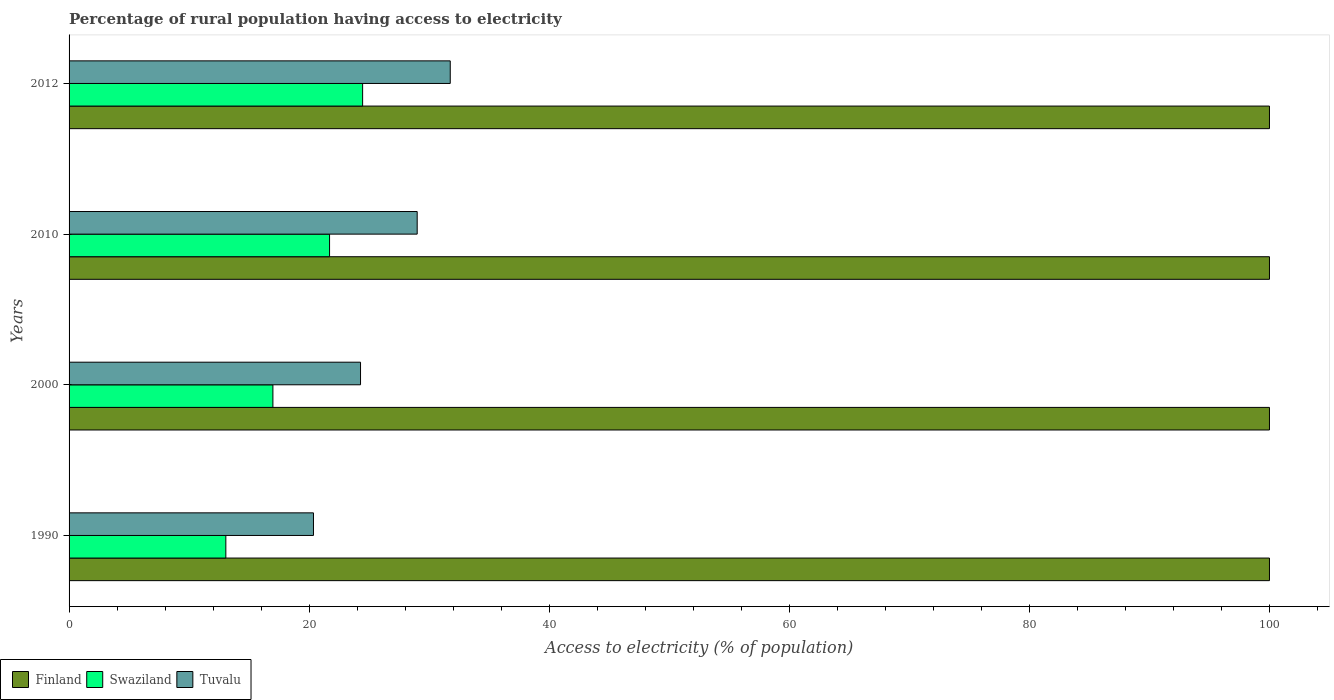How many groups of bars are there?
Offer a very short reply. 4. Are the number of bars on each tick of the Y-axis equal?
Offer a very short reply. Yes. What is the label of the 3rd group of bars from the top?
Provide a short and direct response. 2000. What is the percentage of rural population having access to electricity in Swaziland in 2000?
Make the answer very short. 16.98. Across all years, what is the maximum percentage of rural population having access to electricity in Swaziland?
Your answer should be very brief. 24.45. Across all years, what is the minimum percentage of rural population having access to electricity in Tuvalu?
Provide a short and direct response. 20.36. In which year was the percentage of rural population having access to electricity in Tuvalu maximum?
Ensure brevity in your answer.  2012. In which year was the percentage of rural population having access to electricity in Tuvalu minimum?
Ensure brevity in your answer.  1990. What is the total percentage of rural population having access to electricity in Swaziland in the graph?
Provide a short and direct response. 76.2. What is the difference between the percentage of rural population having access to electricity in Tuvalu in 2000 and that in 2010?
Your answer should be compact. -4.72. What is the difference between the percentage of rural population having access to electricity in Tuvalu in 1990 and the percentage of rural population having access to electricity in Finland in 2010?
Keep it short and to the point. -79.64. In the year 1990, what is the difference between the percentage of rural population having access to electricity in Tuvalu and percentage of rural population having access to electricity in Swaziland?
Provide a short and direct response. 7.3. In how many years, is the percentage of rural population having access to electricity in Tuvalu greater than 44 %?
Make the answer very short. 0. Is the difference between the percentage of rural population having access to electricity in Tuvalu in 1990 and 2000 greater than the difference between the percentage of rural population having access to electricity in Swaziland in 1990 and 2000?
Your answer should be compact. Yes. What is the difference between the highest and the second highest percentage of rural population having access to electricity in Tuvalu?
Offer a terse response. 2.75. What is the difference between the highest and the lowest percentage of rural population having access to electricity in Swaziland?
Your answer should be very brief. 11.39. What does the 2nd bar from the top in 2012 represents?
Keep it short and to the point. Swaziland. What does the 3rd bar from the bottom in 2010 represents?
Ensure brevity in your answer.  Tuvalu. How many bars are there?
Keep it short and to the point. 12. Does the graph contain grids?
Ensure brevity in your answer.  No. Where does the legend appear in the graph?
Make the answer very short. Bottom left. How are the legend labels stacked?
Offer a terse response. Horizontal. What is the title of the graph?
Provide a succinct answer. Percentage of rural population having access to electricity. Does "Bangladesh" appear as one of the legend labels in the graph?
Give a very brief answer. No. What is the label or title of the X-axis?
Your response must be concise. Access to electricity (% of population). What is the Access to electricity (% of population) in Swaziland in 1990?
Provide a short and direct response. 13.06. What is the Access to electricity (% of population) of Tuvalu in 1990?
Your response must be concise. 20.36. What is the Access to electricity (% of population) of Swaziland in 2000?
Your response must be concise. 16.98. What is the Access to electricity (% of population) in Tuvalu in 2000?
Offer a terse response. 24.28. What is the Access to electricity (% of population) of Swaziland in 2010?
Offer a very short reply. 21.7. What is the Access to electricity (% of population) in Tuvalu in 2010?
Your answer should be very brief. 29. What is the Access to electricity (% of population) of Finland in 2012?
Offer a very short reply. 100. What is the Access to electricity (% of population) in Swaziland in 2012?
Provide a short and direct response. 24.45. What is the Access to electricity (% of population) in Tuvalu in 2012?
Ensure brevity in your answer.  31.75. Across all years, what is the maximum Access to electricity (% of population) in Finland?
Your answer should be very brief. 100. Across all years, what is the maximum Access to electricity (% of population) of Swaziland?
Your answer should be compact. 24.45. Across all years, what is the maximum Access to electricity (% of population) of Tuvalu?
Offer a terse response. 31.75. Across all years, what is the minimum Access to electricity (% of population) in Swaziland?
Your answer should be compact. 13.06. Across all years, what is the minimum Access to electricity (% of population) in Tuvalu?
Ensure brevity in your answer.  20.36. What is the total Access to electricity (% of population) in Swaziland in the graph?
Offer a very short reply. 76.2. What is the total Access to electricity (% of population) in Tuvalu in the graph?
Ensure brevity in your answer.  105.4. What is the difference between the Access to electricity (% of population) of Finland in 1990 and that in 2000?
Your answer should be very brief. 0. What is the difference between the Access to electricity (% of population) of Swaziland in 1990 and that in 2000?
Offer a very short reply. -3.92. What is the difference between the Access to electricity (% of population) of Tuvalu in 1990 and that in 2000?
Offer a terse response. -3.92. What is the difference between the Access to electricity (% of population) in Finland in 1990 and that in 2010?
Your answer should be compact. 0. What is the difference between the Access to electricity (% of population) of Swaziland in 1990 and that in 2010?
Ensure brevity in your answer.  -8.64. What is the difference between the Access to electricity (% of population) in Tuvalu in 1990 and that in 2010?
Your answer should be very brief. -8.64. What is the difference between the Access to electricity (% of population) of Finland in 1990 and that in 2012?
Ensure brevity in your answer.  0. What is the difference between the Access to electricity (% of population) of Swaziland in 1990 and that in 2012?
Provide a succinct answer. -11.39. What is the difference between the Access to electricity (% of population) of Tuvalu in 1990 and that in 2012?
Keep it short and to the point. -11.39. What is the difference between the Access to electricity (% of population) in Finland in 2000 and that in 2010?
Make the answer very short. 0. What is the difference between the Access to electricity (% of population) in Swaziland in 2000 and that in 2010?
Offer a terse response. -4.72. What is the difference between the Access to electricity (% of population) of Tuvalu in 2000 and that in 2010?
Your answer should be very brief. -4.72. What is the difference between the Access to electricity (% of population) in Swaziland in 2000 and that in 2012?
Give a very brief answer. -7.47. What is the difference between the Access to electricity (% of population) in Tuvalu in 2000 and that in 2012?
Your response must be concise. -7.47. What is the difference between the Access to electricity (% of population) in Finland in 2010 and that in 2012?
Your answer should be compact. 0. What is the difference between the Access to electricity (% of population) of Swaziland in 2010 and that in 2012?
Keep it short and to the point. -2.75. What is the difference between the Access to electricity (% of population) in Tuvalu in 2010 and that in 2012?
Offer a very short reply. -2.75. What is the difference between the Access to electricity (% of population) in Finland in 1990 and the Access to electricity (% of population) in Swaziland in 2000?
Your response must be concise. 83.02. What is the difference between the Access to electricity (% of population) in Finland in 1990 and the Access to electricity (% of population) in Tuvalu in 2000?
Your answer should be very brief. 75.72. What is the difference between the Access to electricity (% of population) in Swaziland in 1990 and the Access to electricity (% of population) in Tuvalu in 2000?
Offer a very short reply. -11.22. What is the difference between the Access to electricity (% of population) in Finland in 1990 and the Access to electricity (% of population) in Swaziland in 2010?
Provide a short and direct response. 78.3. What is the difference between the Access to electricity (% of population) in Swaziland in 1990 and the Access to electricity (% of population) in Tuvalu in 2010?
Ensure brevity in your answer.  -15.94. What is the difference between the Access to electricity (% of population) in Finland in 1990 and the Access to electricity (% of population) in Swaziland in 2012?
Your answer should be very brief. 75.55. What is the difference between the Access to electricity (% of population) of Finland in 1990 and the Access to electricity (% of population) of Tuvalu in 2012?
Provide a succinct answer. 68.25. What is the difference between the Access to electricity (% of population) of Swaziland in 1990 and the Access to electricity (% of population) of Tuvalu in 2012?
Offer a very short reply. -18.69. What is the difference between the Access to electricity (% of population) in Finland in 2000 and the Access to electricity (% of population) in Swaziland in 2010?
Provide a short and direct response. 78.3. What is the difference between the Access to electricity (% of population) of Finland in 2000 and the Access to electricity (% of population) of Tuvalu in 2010?
Keep it short and to the point. 71. What is the difference between the Access to electricity (% of population) of Swaziland in 2000 and the Access to electricity (% of population) of Tuvalu in 2010?
Ensure brevity in your answer.  -12.02. What is the difference between the Access to electricity (% of population) of Finland in 2000 and the Access to electricity (% of population) of Swaziland in 2012?
Offer a terse response. 75.55. What is the difference between the Access to electricity (% of population) in Finland in 2000 and the Access to electricity (% of population) in Tuvalu in 2012?
Offer a terse response. 68.25. What is the difference between the Access to electricity (% of population) in Swaziland in 2000 and the Access to electricity (% of population) in Tuvalu in 2012?
Provide a short and direct response. -14.77. What is the difference between the Access to electricity (% of population) of Finland in 2010 and the Access to electricity (% of population) of Swaziland in 2012?
Offer a very short reply. 75.55. What is the difference between the Access to electricity (% of population) in Finland in 2010 and the Access to electricity (% of population) in Tuvalu in 2012?
Your answer should be very brief. 68.25. What is the difference between the Access to electricity (% of population) of Swaziland in 2010 and the Access to electricity (% of population) of Tuvalu in 2012?
Give a very brief answer. -10.05. What is the average Access to electricity (% of population) in Finland per year?
Provide a succinct answer. 100. What is the average Access to electricity (% of population) in Swaziland per year?
Your response must be concise. 19.05. What is the average Access to electricity (% of population) of Tuvalu per year?
Give a very brief answer. 26.35. In the year 1990, what is the difference between the Access to electricity (% of population) of Finland and Access to electricity (% of population) of Swaziland?
Make the answer very short. 86.94. In the year 1990, what is the difference between the Access to electricity (% of population) of Finland and Access to electricity (% of population) of Tuvalu?
Offer a terse response. 79.64. In the year 2000, what is the difference between the Access to electricity (% of population) in Finland and Access to electricity (% of population) in Swaziland?
Give a very brief answer. 83.02. In the year 2000, what is the difference between the Access to electricity (% of population) of Finland and Access to electricity (% of population) of Tuvalu?
Make the answer very short. 75.72. In the year 2010, what is the difference between the Access to electricity (% of population) of Finland and Access to electricity (% of population) of Swaziland?
Make the answer very short. 78.3. In the year 2010, what is the difference between the Access to electricity (% of population) in Finland and Access to electricity (% of population) in Tuvalu?
Your answer should be compact. 71. In the year 2010, what is the difference between the Access to electricity (% of population) of Swaziland and Access to electricity (% of population) of Tuvalu?
Make the answer very short. -7.3. In the year 2012, what is the difference between the Access to electricity (% of population) of Finland and Access to electricity (% of population) of Swaziland?
Keep it short and to the point. 75.55. In the year 2012, what is the difference between the Access to electricity (% of population) in Finland and Access to electricity (% of population) in Tuvalu?
Offer a terse response. 68.25. What is the ratio of the Access to electricity (% of population) of Finland in 1990 to that in 2000?
Keep it short and to the point. 1. What is the ratio of the Access to electricity (% of population) of Swaziland in 1990 to that in 2000?
Make the answer very short. 0.77. What is the ratio of the Access to electricity (% of population) in Tuvalu in 1990 to that in 2000?
Your response must be concise. 0.84. What is the ratio of the Access to electricity (% of population) of Swaziland in 1990 to that in 2010?
Offer a very short reply. 0.6. What is the ratio of the Access to electricity (% of population) in Tuvalu in 1990 to that in 2010?
Your answer should be compact. 0.7. What is the ratio of the Access to electricity (% of population) of Finland in 1990 to that in 2012?
Give a very brief answer. 1. What is the ratio of the Access to electricity (% of population) of Swaziland in 1990 to that in 2012?
Your answer should be compact. 0.53. What is the ratio of the Access to electricity (% of population) in Tuvalu in 1990 to that in 2012?
Your answer should be very brief. 0.64. What is the ratio of the Access to electricity (% of population) of Swaziland in 2000 to that in 2010?
Offer a very short reply. 0.78. What is the ratio of the Access to electricity (% of population) of Tuvalu in 2000 to that in 2010?
Keep it short and to the point. 0.84. What is the ratio of the Access to electricity (% of population) of Swaziland in 2000 to that in 2012?
Your response must be concise. 0.69. What is the ratio of the Access to electricity (% of population) of Tuvalu in 2000 to that in 2012?
Provide a succinct answer. 0.76. What is the ratio of the Access to electricity (% of population) in Finland in 2010 to that in 2012?
Provide a short and direct response. 1. What is the ratio of the Access to electricity (% of population) in Swaziland in 2010 to that in 2012?
Offer a very short reply. 0.89. What is the ratio of the Access to electricity (% of population) of Tuvalu in 2010 to that in 2012?
Keep it short and to the point. 0.91. What is the difference between the highest and the second highest Access to electricity (% of population) of Finland?
Make the answer very short. 0. What is the difference between the highest and the second highest Access to electricity (% of population) of Swaziland?
Ensure brevity in your answer.  2.75. What is the difference between the highest and the second highest Access to electricity (% of population) of Tuvalu?
Provide a succinct answer. 2.75. What is the difference between the highest and the lowest Access to electricity (% of population) in Swaziland?
Your answer should be very brief. 11.39. What is the difference between the highest and the lowest Access to electricity (% of population) in Tuvalu?
Provide a succinct answer. 11.39. 